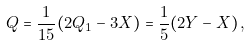Convert formula to latex. <formula><loc_0><loc_0><loc_500><loc_500>Q = \frac { 1 } { 1 5 } ( 2 Q _ { 1 } - 3 X ) = \frac { 1 } { 5 } ( 2 Y - X ) \, ,</formula> 